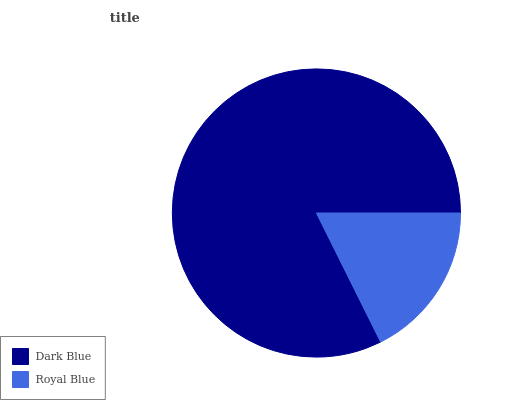Is Royal Blue the minimum?
Answer yes or no. Yes. Is Dark Blue the maximum?
Answer yes or no. Yes. Is Royal Blue the maximum?
Answer yes or no. No. Is Dark Blue greater than Royal Blue?
Answer yes or no. Yes. Is Royal Blue less than Dark Blue?
Answer yes or no. Yes. Is Royal Blue greater than Dark Blue?
Answer yes or no. No. Is Dark Blue less than Royal Blue?
Answer yes or no. No. Is Dark Blue the high median?
Answer yes or no. Yes. Is Royal Blue the low median?
Answer yes or no. Yes. Is Royal Blue the high median?
Answer yes or no. No. Is Dark Blue the low median?
Answer yes or no. No. 